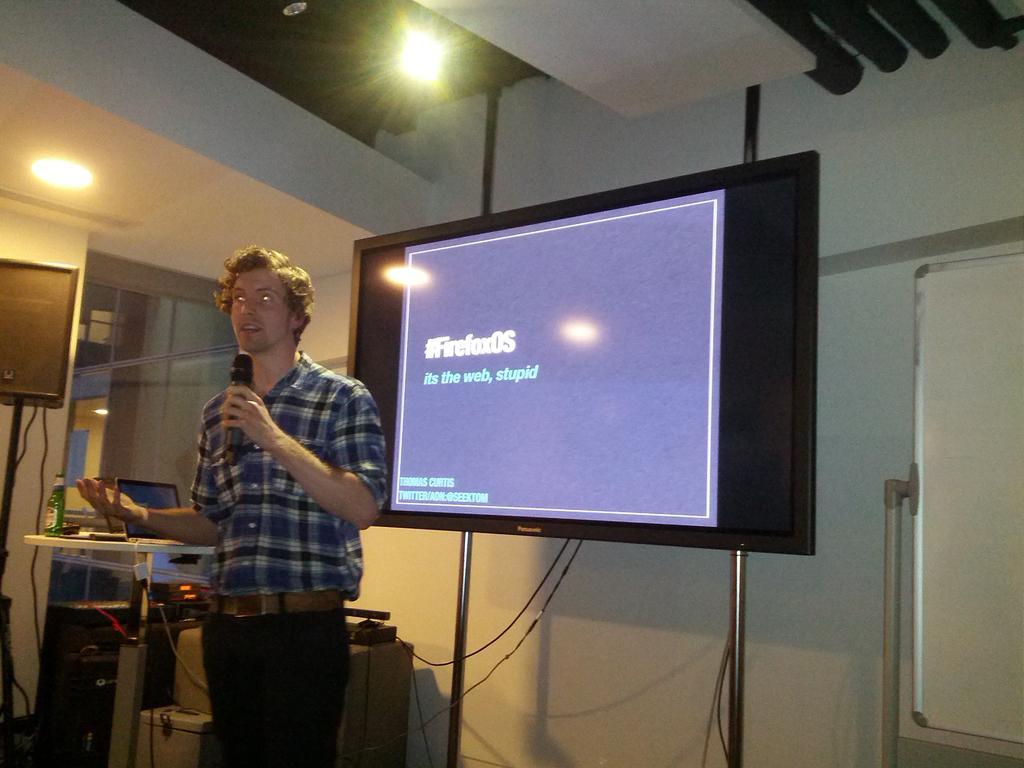How would you summarize this image in a sentence or two? This image consists of a man wearing a blue shirt and holding a mic. Beside him, there is a screen. At the bottom, there is a floor. On the left, there are many things kept near the table. At the top, there are lights to the roof. 